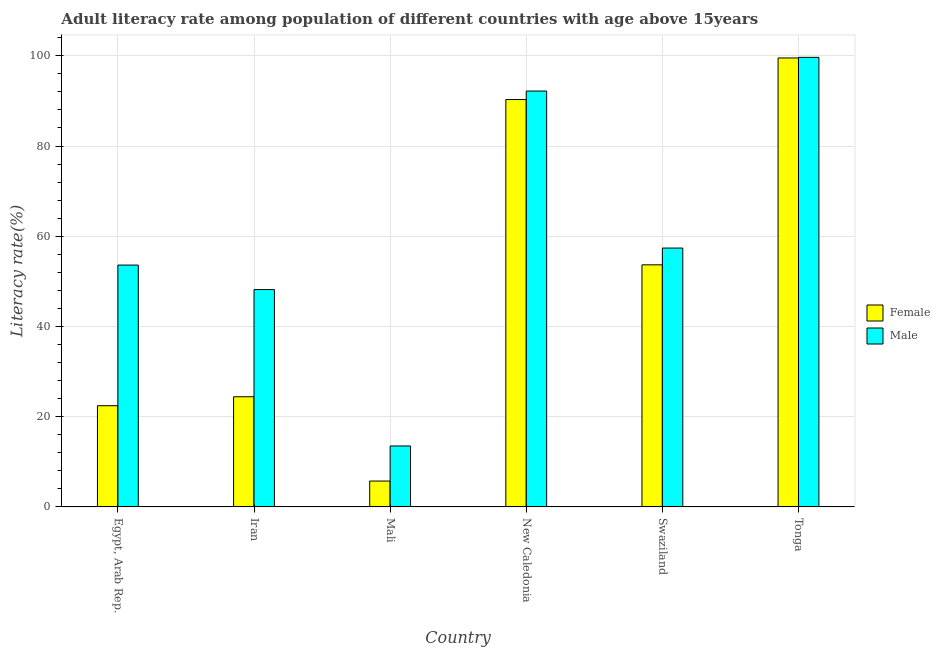How many groups of bars are there?
Provide a succinct answer. 6. Are the number of bars on each tick of the X-axis equal?
Keep it short and to the point. Yes. How many bars are there on the 4th tick from the right?
Give a very brief answer. 2. What is the label of the 6th group of bars from the left?
Your answer should be compact. Tonga. What is the female adult literacy rate in Swaziland?
Provide a succinct answer. 53.67. Across all countries, what is the maximum male adult literacy rate?
Ensure brevity in your answer.  99.66. Across all countries, what is the minimum male adult literacy rate?
Offer a terse response. 13.51. In which country was the male adult literacy rate maximum?
Offer a very short reply. Tonga. In which country was the male adult literacy rate minimum?
Ensure brevity in your answer.  Mali. What is the total male adult literacy rate in the graph?
Your response must be concise. 364.55. What is the difference between the female adult literacy rate in Mali and that in New Caledonia?
Give a very brief answer. -84.58. What is the difference between the female adult literacy rate in New Caledonia and the male adult literacy rate in Egypt, Arab Rep.?
Your answer should be compact. 36.7. What is the average male adult literacy rate per country?
Ensure brevity in your answer.  60.76. What is the difference between the female adult literacy rate and male adult literacy rate in Mali?
Give a very brief answer. -7.78. What is the ratio of the female adult literacy rate in Egypt, Arab Rep. to that in Mali?
Offer a very short reply. 3.91. Is the difference between the female adult literacy rate in Mali and Swaziland greater than the difference between the male adult literacy rate in Mali and Swaziland?
Provide a succinct answer. No. What is the difference between the highest and the second highest female adult literacy rate?
Offer a terse response. 9.21. What is the difference between the highest and the lowest male adult literacy rate?
Ensure brevity in your answer.  86.15. In how many countries, is the male adult literacy rate greater than the average male adult literacy rate taken over all countries?
Offer a terse response. 2. Is the sum of the male adult literacy rate in Egypt, Arab Rep. and New Caledonia greater than the maximum female adult literacy rate across all countries?
Offer a terse response. Yes. How many bars are there?
Your response must be concise. 12. Are the values on the major ticks of Y-axis written in scientific E-notation?
Ensure brevity in your answer.  No. What is the title of the graph?
Keep it short and to the point. Adult literacy rate among population of different countries with age above 15years. What is the label or title of the X-axis?
Keep it short and to the point. Country. What is the label or title of the Y-axis?
Offer a very short reply. Literacy rate(%). What is the Literacy rate(%) in Female in Egypt, Arab Rep.?
Give a very brief answer. 22.44. What is the Literacy rate(%) in Male in Egypt, Arab Rep.?
Give a very brief answer. 53.62. What is the Literacy rate(%) of Female in Iran?
Your answer should be very brief. 24.42. What is the Literacy rate(%) in Male in Iran?
Keep it short and to the point. 48.18. What is the Literacy rate(%) of Female in Mali?
Your response must be concise. 5.74. What is the Literacy rate(%) of Male in Mali?
Offer a very short reply. 13.51. What is the Literacy rate(%) in Female in New Caledonia?
Offer a terse response. 90.31. What is the Literacy rate(%) in Male in New Caledonia?
Your answer should be compact. 92.19. What is the Literacy rate(%) of Female in Swaziland?
Make the answer very short. 53.67. What is the Literacy rate(%) of Male in Swaziland?
Provide a succinct answer. 57.38. What is the Literacy rate(%) in Female in Tonga?
Offer a terse response. 99.53. What is the Literacy rate(%) of Male in Tonga?
Provide a succinct answer. 99.66. Across all countries, what is the maximum Literacy rate(%) of Female?
Make the answer very short. 99.53. Across all countries, what is the maximum Literacy rate(%) in Male?
Provide a succinct answer. 99.66. Across all countries, what is the minimum Literacy rate(%) of Female?
Provide a short and direct response. 5.74. Across all countries, what is the minimum Literacy rate(%) in Male?
Make the answer very short. 13.51. What is the total Literacy rate(%) in Female in the graph?
Offer a very short reply. 296.1. What is the total Literacy rate(%) of Male in the graph?
Keep it short and to the point. 364.55. What is the difference between the Literacy rate(%) of Female in Egypt, Arab Rep. and that in Iran?
Give a very brief answer. -1.99. What is the difference between the Literacy rate(%) of Male in Egypt, Arab Rep. and that in Iran?
Give a very brief answer. 5.43. What is the difference between the Literacy rate(%) of Female in Egypt, Arab Rep. and that in Mali?
Your answer should be very brief. 16.7. What is the difference between the Literacy rate(%) in Male in Egypt, Arab Rep. and that in Mali?
Provide a succinct answer. 40.1. What is the difference between the Literacy rate(%) of Female in Egypt, Arab Rep. and that in New Caledonia?
Keep it short and to the point. -67.87. What is the difference between the Literacy rate(%) in Male in Egypt, Arab Rep. and that in New Caledonia?
Keep it short and to the point. -38.58. What is the difference between the Literacy rate(%) of Female in Egypt, Arab Rep. and that in Swaziland?
Make the answer very short. -31.23. What is the difference between the Literacy rate(%) in Male in Egypt, Arab Rep. and that in Swaziland?
Ensure brevity in your answer.  -3.77. What is the difference between the Literacy rate(%) of Female in Egypt, Arab Rep. and that in Tonga?
Provide a short and direct response. -77.09. What is the difference between the Literacy rate(%) of Male in Egypt, Arab Rep. and that in Tonga?
Give a very brief answer. -46.04. What is the difference between the Literacy rate(%) of Female in Iran and that in Mali?
Your answer should be very brief. 18.69. What is the difference between the Literacy rate(%) in Male in Iran and that in Mali?
Your answer should be compact. 34.67. What is the difference between the Literacy rate(%) in Female in Iran and that in New Caledonia?
Keep it short and to the point. -65.89. What is the difference between the Literacy rate(%) of Male in Iran and that in New Caledonia?
Give a very brief answer. -44.01. What is the difference between the Literacy rate(%) in Female in Iran and that in Swaziland?
Your answer should be very brief. -29.24. What is the difference between the Literacy rate(%) in Male in Iran and that in Swaziland?
Provide a succinct answer. -9.2. What is the difference between the Literacy rate(%) in Female in Iran and that in Tonga?
Provide a succinct answer. -75.1. What is the difference between the Literacy rate(%) of Male in Iran and that in Tonga?
Ensure brevity in your answer.  -51.48. What is the difference between the Literacy rate(%) of Female in Mali and that in New Caledonia?
Offer a very short reply. -84.58. What is the difference between the Literacy rate(%) of Male in Mali and that in New Caledonia?
Give a very brief answer. -78.68. What is the difference between the Literacy rate(%) in Female in Mali and that in Swaziland?
Make the answer very short. -47.93. What is the difference between the Literacy rate(%) in Male in Mali and that in Swaziland?
Make the answer very short. -43.87. What is the difference between the Literacy rate(%) of Female in Mali and that in Tonga?
Provide a succinct answer. -93.79. What is the difference between the Literacy rate(%) of Male in Mali and that in Tonga?
Provide a succinct answer. -86.15. What is the difference between the Literacy rate(%) in Female in New Caledonia and that in Swaziland?
Your answer should be compact. 36.64. What is the difference between the Literacy rate(%) in Male in New Caledonia and that in Swaziland?
Your answer should be very brief. 34.81. What is the difference between the Literacy rate(%) of Female in New Caledonia and that in Tonga?
Give a very brief answer. -9.21. What is the difference between the Literacy rate(%) in Male in New Caledonia and that in Tonga?
Offer a very short reply. -7.47. What is the difference between the Literacy rate(%) of Female in Swaziland and that in Tonga?
Keep it short and to the point. -45.86. What is the difference between the Literacy rate(%) in Male in Swaziland and that in Tonga?
Make the answer very short. -42.27. What is the difference between the Literacy rate(%) in Female in Egypt, Arab Rep. and the Literacy rate(%) in Male in Iran?
Offer a very short reply. -25.75. What is the difference between the Literacy rate(%) of Female in Egypt, Arab Rep. and the Literacy rate(%) of Male in Mali?
Offer a terse response. 8.93. What is the difference between the Literacy rate(%) of Female in Egypt, Arab Rep. and the Literacy rate(%) of Male in New Caledonia?
Your response must be concise. -69.75. What is the difference between the Literacy rate(%) of Female in Egypt, Arab Rep. and the Literacy rate(%) of Male in Swaziland?
Offer a very short reply. -34.95. What is the difference between the Literacy rate(%) of Female in Egypt, Arab Rep. and the Literacy rate(%) of Male in Tonga?
Keep it short and to the point. -77.22. What is the difference between the Literacy rate(%) in Female in Iran and the Literacy rate(%) in Male in Mali?
Offer a terse response. 10.91. What is the difference between the Literacy rate(%) of Female in Iran and the Literacy rate(%) of Male in New Caledonia?
Give a very brief answer. -67.77. What is the difference between the Literacy rate(%) in Female in Iran and the Literacy rate(%) in Male in Swaziland?
Give a very brief answer. -32.96. What is the difference between the Literacy rate(%) in Female in Iran and the Literacy rate(%) in Male in Tonga?
Ensure brevity in your answer.  -75.24. What is the difference between the Literacy rate(%) of Female in Mali and the Literacy rate(%) of Male in New Caledonia?
Your answer should be very brief. -86.46. What is the difference between the Literacy rate(%) of Female in Mali and the Literacy rate(%) of Male in Swaziland?
Make the answer very short. -51.65. What is the difference between the Literacy rate(%) in Female in Mali and the Literacy rate(%) in Male in Tonga?
Your answer should be compact. -93.92. What is the difference between the Literacy rate(%) of Female in New Caledonia and the Literacy rate(%) of Male in Swaziland?
Provide a succinct answer. 32.93. What is the difference between the Literacy rate(%) in Female in New Caledonia and the Literacy rate(%) in Male in Tonga?
Ensure brevity in your answer.  -9.35. What is the difference between the Literacy rate(%) in Female in Swaziland and the Literacy rate(%) in Male in Tonga?
Offer a very short reply. -45.99. What is the average Literacy rate(%) in Female per country?
Your answer should be very brief. 49.35. What is the average Literacy rate(%) of Male per country?
Your response must be concise. 60.76. What is the difference between the Literacy rate(%) in Female and Literacy rate(%) in Male in Egypt, Arab Rep.?
Offer a terse response. -31.18. What is the difference between the Literacy rate(%) of Female and Literacy rate(%) of Male in Iran?
Make the answer very short. -23.76. What is the difference between the Literacy rate(%) of Female and Literacy rate(%) of Male in Mali?
Provide a short and direct response. -7.78. What is the difference between the Literacy rate(%) in Female and Literacy rate(%) in Male in New Caledonia?
Provide a short and direct response. -1.88. What is the difference between the Literacy rate(%) of Female and Literacy rate(%) of Male in Swaziland?
Provide a short and direct response. -3.72. What is the difference between the Literacy rate(%) in Female and Literacy rate(%) in Male in Tonga?
Your answer should be compact. -0.13. What is the ratio of the Literacy rate(%) of Female in Egypt, Arab Rep. to that in Iran?
Provide a succinct answer. 0.92. What is the ratio of the Literacy rate(%) of Male in Egypt, Arab Rep. to that in Iran?
Ensure brevity in your answer.  1.11. What is the ratio of the Literacy rate(%) of Female in Egypt, Arab Rep. to that in Mali?
Offer a very short reply. 3.91. What is the ratio of the Literacy rate(%) of Male in Egypt, Arab Rep. to that in Mali?
Your answer should be compact. 3.97. What is the ratio of the Literacy rate(%) in Female in Egypt, Arab Rep. to that in New Caledonia?
Your response must be concise. 0.25. What is the ratio of the Literacy rate(%) of Male in Egypt, Arab Rep. to that in New Caledonia?
Your answer should be compact. 0.58. What is the ratio of the Literacy rate(%) of Female in Egypt, Arab Rep. to that in Swaziland?
Offer a very short reply. 0.42. What is the ratio of the Literacy rate(%) of Male in Egypt, Arab Rep. to that in Swaziland?
Provide a short and direct response. 0.93. What is the ratio of the Literacy rate(%) in Female in Egypt, Arab Rep. to that in Tonga?
Your answer should be very brief. 0.23. What is the ratio of the Literacy rate(%) of Male in Egypt, Arab Rep. to that in Tonga?
Provide a succinct answer. 0.54. What is the ratio of the Literacy rate(%) of Female in Iran to that in Mali?
Provide a short and direct response. 4.26. What is the ratio of the Literacy rate(%) in Male in Iran to that in Mali?
Give a very brief answer. 3.57. What is the ratio of the Literacy rate(%) of Female in Iran to that in New Caledonia?
Your answer should be compact. 0.27. What is the ratio of the Literacy rate(%) in Male in Iran to that in New Caledonia?
Offer a very short reply. 0.52. What is the ratio of the Literacy rate(%) in Female in Iran to that in Swaziland?
Your answer should be compact. 0.46. What is the ratio of the Literacy rate(%) in Male in Iran to that in Swaziland?
Your response must be concise. 0.84. What is the ratio of the Literacy rate(%) in Female in Iran to that in Tonga?
Provide a succinct answer. 0.25. What is the ratio of the Literacy rate(%) in Male in Iran to that in Tonga?
Offer a terse response. 0.48. What is the ratio of the Literacy rate(%) in Female in Mali to that in New Caledonia?
Make the answer very short. 0.06. What is the ratio of the Literacy rate(%) in Male in Mali to that in New Caledonia?
Ensure brevity in your answer.  0.15. What is the ratio of the Literacy rate(%) of Female in Mali to that in Swaziland?
Your answer should be very brief. 0.11. What is the ratio of the Literacy rate(%) of Male in Mali to that in Swaziland?
Offer a very short reply. 0.24. What is the ratio of the Literacy rate(%) of Female in Mali to that in Tonga?
Provide a short and direct response. 0.06. What is the ratio of the Literacy rate(%) in Male in Mali to that in Tonga?
Your answer should be compact. 0.14. What is the ratio of the Literacy rate(%) of Female in New Caledonia to that in Swaziland?
Make the answer very short. 1.68. What is the ratio of the Literacy rate(%) of Male in New Caledonia to that in Swaziland?
Your response must be concise. 1.61. What is the ratio of the Literacy rate(%) in Female in New Caledonia to that in Tonga?
Your answer should be compact. 0.91. What is the ratio of the Literacy rate(%) in Male in New Caledonia to that in Tonga?
Offer a very short reply. 0.93. What is the ratio of the Literacy rate(%) in Female in Swaziland to that in Tonga?
Your answer should be compact. 0.54. What is the ratio of the Literacy rate(%) of Male in Swaziland to that in Tonga?
Your response must be concise. 0.58. What is the difference between the highest and the second highest Literacy rate(%) in Female?
Provide a succinct answer. 9.21. What is the difference between the highest and the second highest Literacy rate(%) of Male?
Your answer should be compact. 7.47. What is the difference between the highest and the lowest Literacy rate(%) in Female?
Your response must be concise. 93.79. What is the difference between the highest and the lowest Literacy rate(%) in Male?
Offer a very short reply. 86.15. 